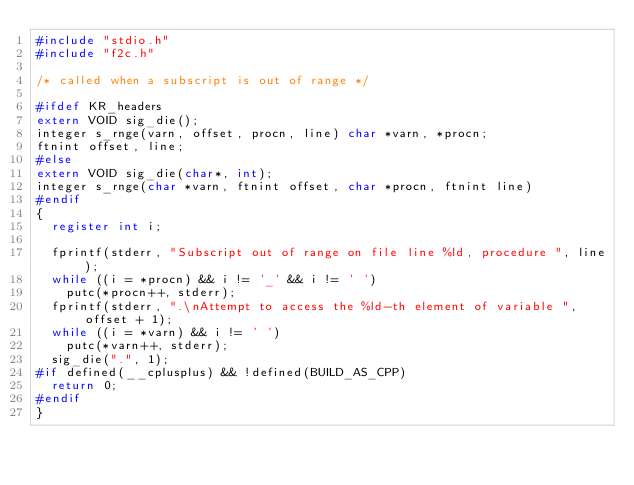Convert code to text. <code><loc_0><loc_0><loc_500><loc_500><_C_>#include "stdio.h"
#include "f2c.h"

/* called when a subscript is out of range */

#ifdef KR_headers
extern VOID sig_die();
integer s_rnge(varn, offset, procn, line) char *varn, *procn;
ftnint offset, line;
#else
extern VOID sig_die(char*, int);
integer s_rnge(char *varn, ftnint offset, char *procn, ftnint line)
#endif
{
  register int i;

  fprintf(stderr, "Subscript out of range on file line %ld, procedure ", line);
  while ((i = *procn) && i != '_' && i != ' ')
    putc(*procn++, stderr);
  fprintf(stderr, ".\nAttempt to access the %ld-th element of variable ", offset + 1);
  while ((i = *varn) && i != ' ')
    putc(*varn++, stderr);
  sig_die(".", 1);
#if defined(__cplusplus) && !defined(BUILD_AS_CPP)
  return 0;
#endif
}
</code> 